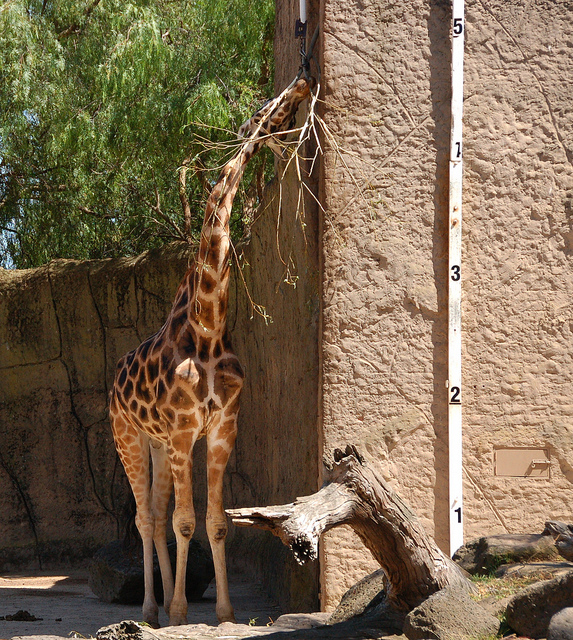Read all the text in this image. 5 1 3 2 1 